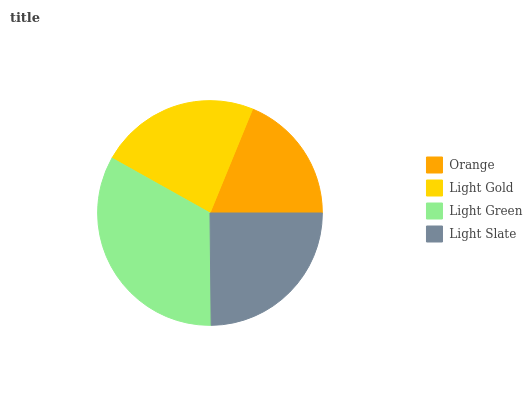Is Orange the minimum?
Answer yes or no. Yes. Is Light Green the maximum?
Answer yes or no. Yes. Is Light Gold the minimum?
Answer yes or no. No. Is Light Gold the maximum?
Answer yes or no. No. Is Light Gold greater than Orange?
Answer yes or no. Yes. Is Orange less than Light Gold?
Answer yes or no. Yes. Is Orange greater than Light Gold?
Answer yes or no. No. Is Light Gold less than Orange?
Answer yes or no. No. Is Light Slate the high median?
Answer yes or no. Yes. Is Light Gold the low median?
Answer yes or no. Yes. Is Orange the high median?
Answer yes or no. No. Is Light Green the low median?
Answer yes or no. No. 